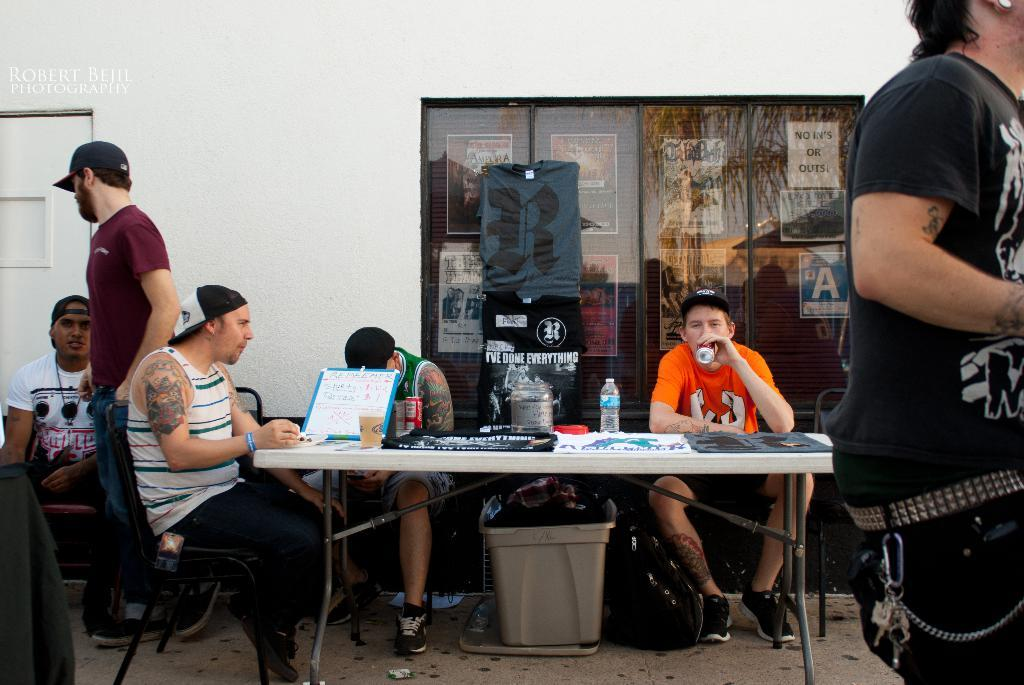How many people are in the image? There are multiple people in the image. What are the people in the image doing? Some people are standing, while others are sitting. What type of objects can be seen in the image related to beverages? There is a bottle and a cup visible in the image. Is there any visible pain being experienced by the people in the image? There is no indication of pain being experienced by the people in the image. Can you see any cobwebs in the image? There is no mention of cobwebs in the image, and they are not visible in the provided facts. 